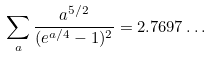Convert formula to latex. <formula><loc_0><loc_0><loc_500><loc_500>\sum _ { a } \frac { a ^ { 5 / 2 } } { ( e ^ { a / 4 } - 1 ) ^ { 2 } } = 2 . 7 6 9 7 \dots</formula> 